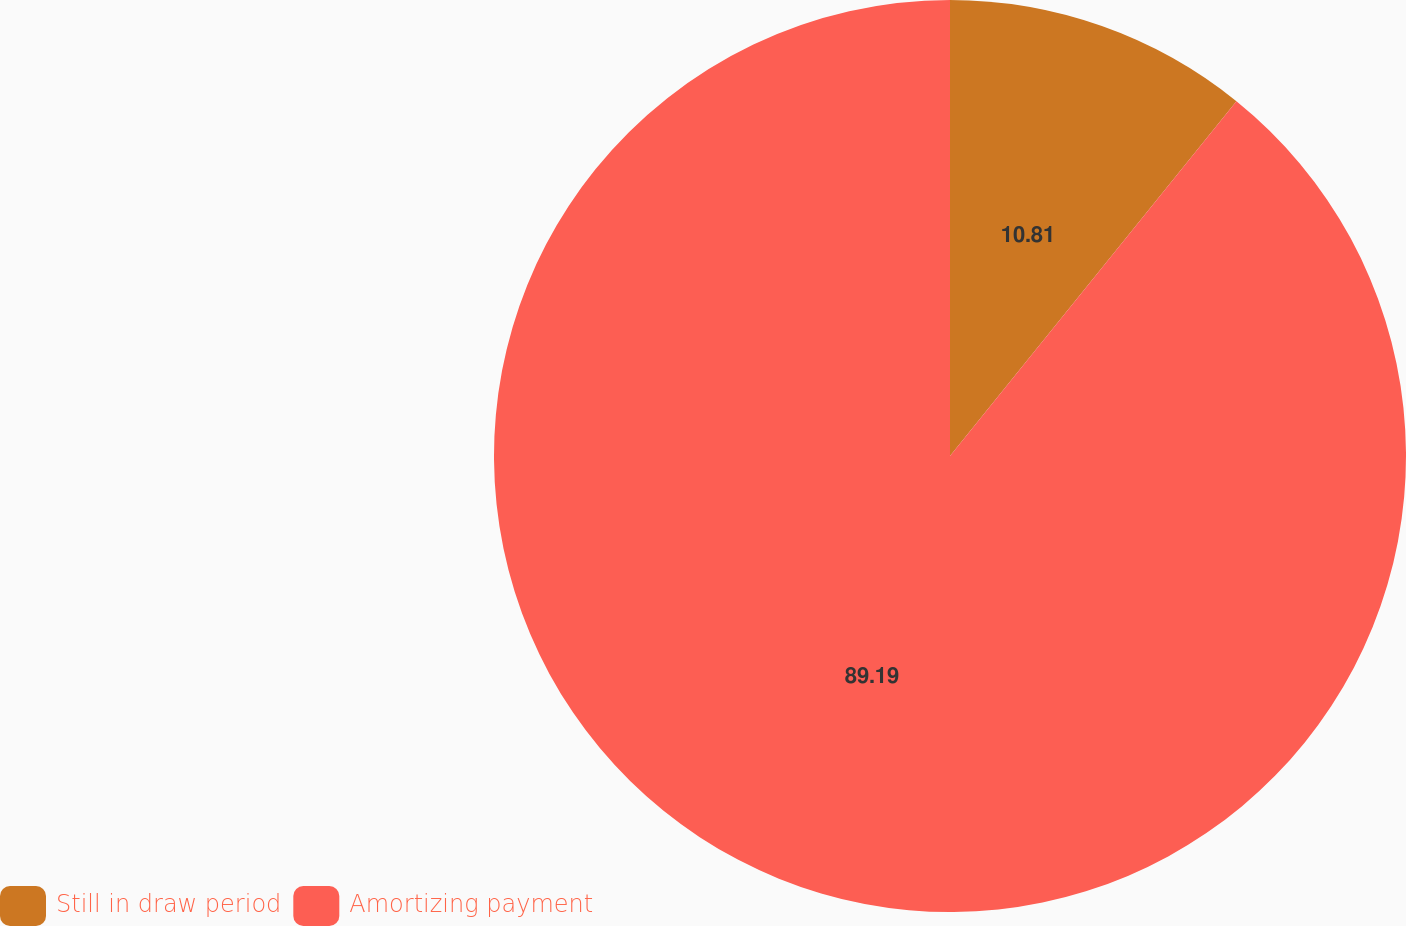<chart> <loc_0><loc_0><loc_500><loc_500><pie_chart><fcel>Still in draw period<fcel>Amortizing payment<nl><fcel>10.81%<fcel>89.19%<nl></chart> 